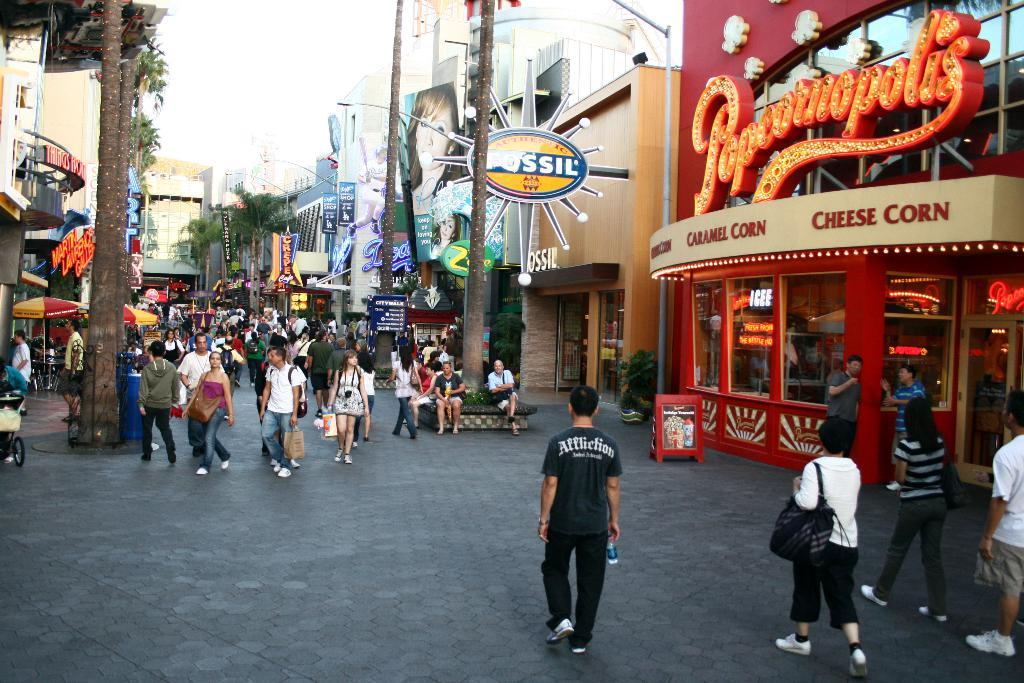What are the people in the image doing? The people in the image are walking on the road. What objects can be seen along the road? Boards and light poles are visible in the image. What type of vegetation is present in the image? Trees are present in the image. What type of establishments can be seen in the image? Stores and buildings are visible in the image. What might people be using to protect themselves from the elements? Umbrellas are present in the image. What is visible in the background of the image? The sky is visible in the background of the image. How many trains can be seen in the image? There are no trains present in the image. What type of paper is being used by the zebra in the image? There is no zebra present in the image, and therefore no paper usage can be observed. 